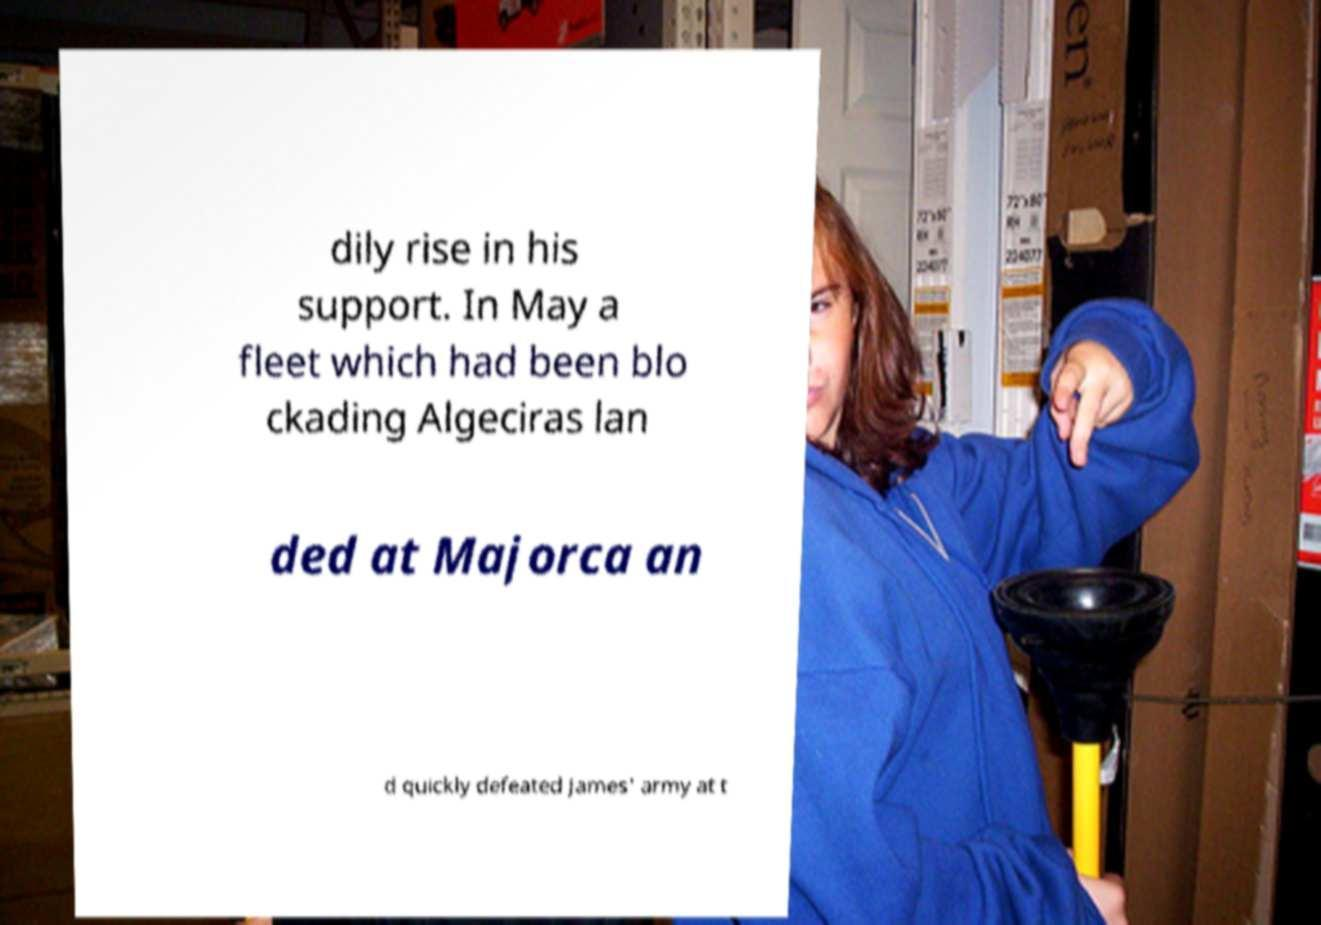Please identify and transcribe the text found in this image. dily rise in his support. In May a fleet which had been blo ckading Algeciras lan ded at Majorca an d quickly defeated James' army at t 